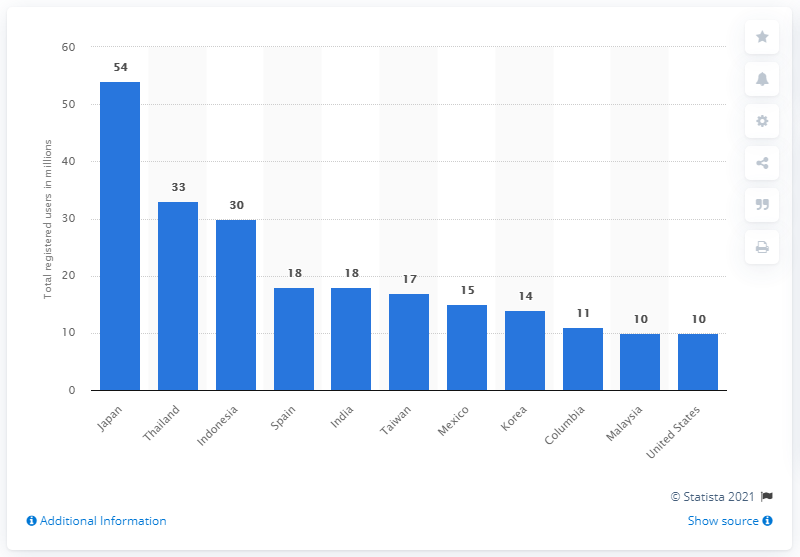Indicate a few pertinent items in this graphic. In October 2014, LINE had 33 users in Indonesia. 